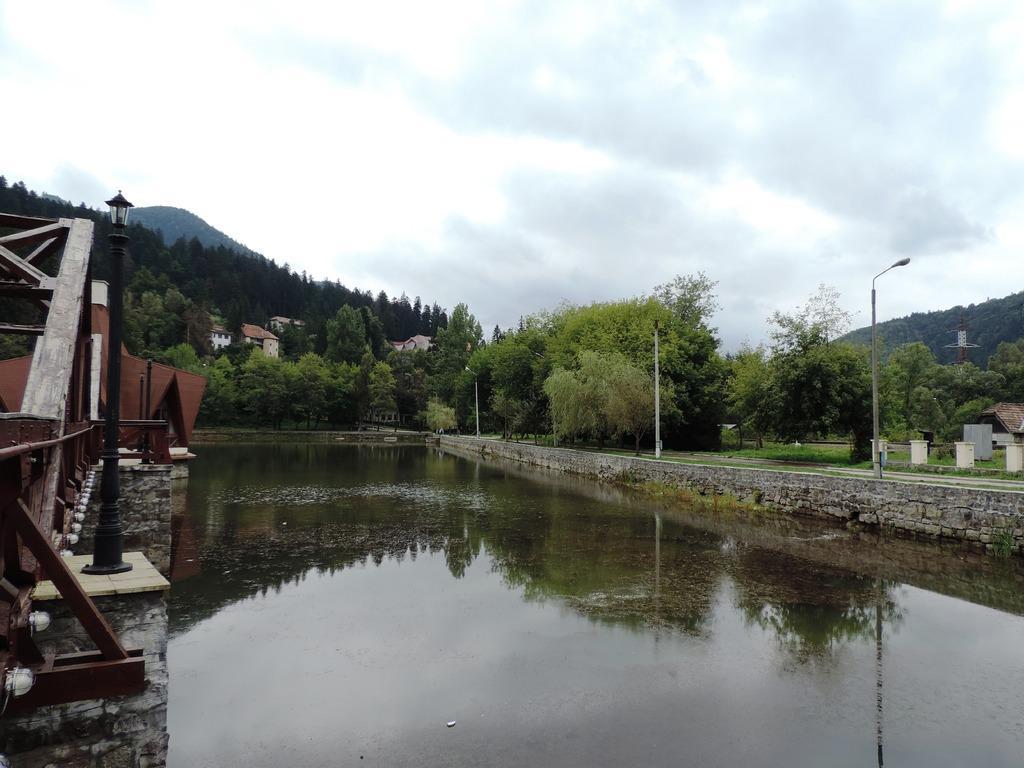Can you describe this image briefly? In this picture I can see there is a lake and a bridge on to left side and in the backdrop there are trees, buildings, street light poles and there are mountains here and the sky is clear. 